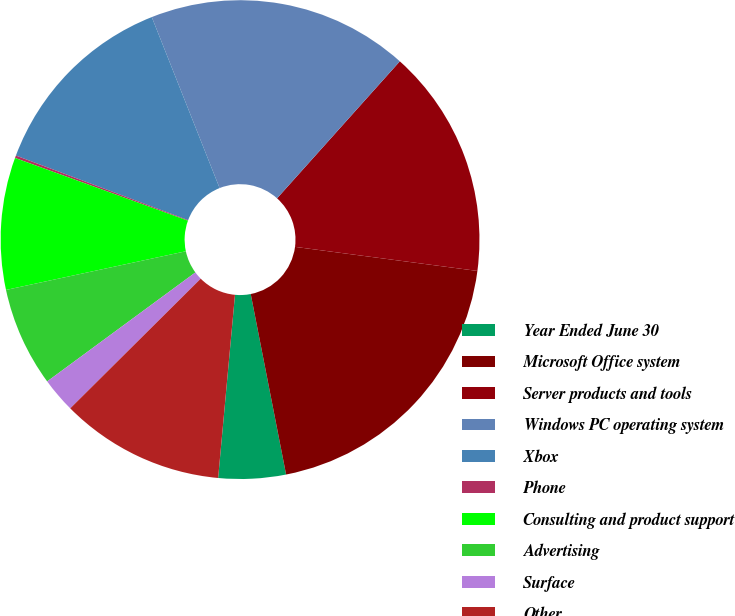Convert chart to OTSL. <chart><loc_0><loc_0><loc_500><loc_500><pie_chart><fcel>Year Ended June 30<fcel>Microsoft Office system<fcel>Server products and tools<fcel>Windows PC operating system<fcel>Xbox<fcel>Phone<fcel>Consulting and product support<fcel>Advertising<fcel>Surface<fcel>Other<nl><fcel>4.54%<fcel>19.83%<fcel>15.46%<fcel>17.64%<fcel>13.28%<fcel>0.17%<fcel>8.91%<fcel>6.72%<fcel>2.36%<fcel>11.09%<nl></chart> 